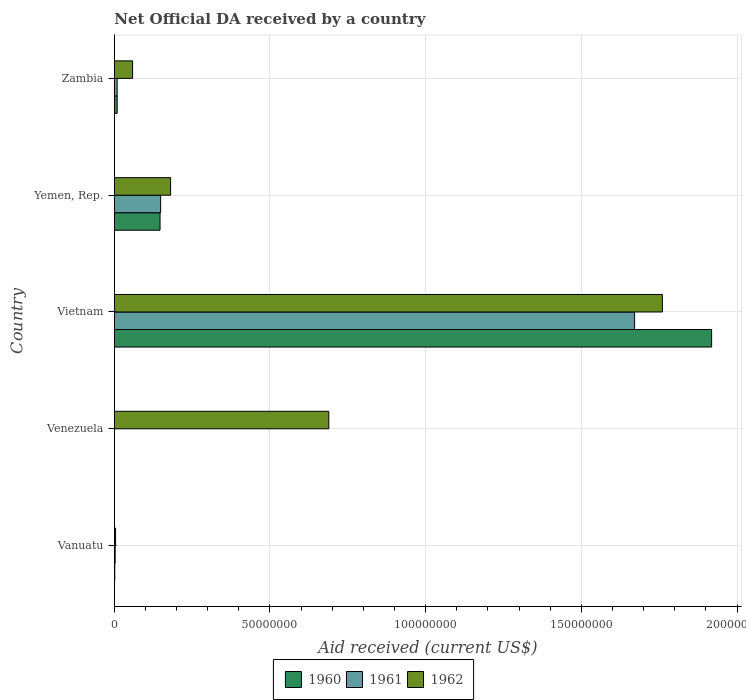Are the number of bars per tick equal to the number of legend labels?
Give a very brief answer. No. How many bars are there on the 4th tick from the top?
Ensure brevity in your answer.  1. What is the label of the 5th group of bars from the top?
Keep it short and to the point. Vanuatu. In how many cases, is the number of bars for a given country not equal to the number of legend labels?
Ensure brevity in your answer.  1. What is the net official development assistance aid received in 1961 in Vietnam?
Offer a terse response. 1.67e+08. Across all countries, what is the maximum net official development assistance aid received in 1960?
Give a very brief answer. 1.92e+08. In which country was the net official development assistance aid received in 1961 maximum?
Offer a very short reply. Vietnam. What is the total net official development assistance aid received in 1962 in the graph?
Offer a very short reply. 2.69e+08. What is the difference between the net official development assistance aid received in 1961 in Vietnam and that in Yemen, Rep.?
Give a very brief answer. 1.52e+08. What is the difference between the net official development assistance aid received in 1961 in Vietnam and the net official development assistance aid received in 1962 in Zambia?
Offer a very short reply. 1.61e+08. What is the average net official development assistance aid received in 1962 per country?
Keep it short and to the point. 5.39e+07. What is the difference between the net official development assistance aid received in 1960 and net official development assistance aid received in 1962 in Yemen, Rep.?
Offer a terse response. -3.39e+06. What is the ratio of the net official development assistance aid received in 1962 in Vanuatu to that in Yemen, Rep.?
Keep it short and to the point. 0.02. Is the difference between the net official development assistance aid received in 1960 in Vanuatu and Zambia greater than the difference between the net official development assistance aid received in 1962 in Vanuatu and Zambia?
Provide a short and direct response. Yes. What is the difference between the highest and the second highest net official development assistance aid received in 1961?
Your answer should be compact. 1.52e+08. What is the difference between the highest and the lowest net official development assistance aid received in 1962?
Offer a very short reply. 1.76e+08. In how many countries, is the net official development assistance aid received in 1961 greater than the average net official development assistance aid received in 1961 taken over all countries?
Offer a very short reply. 1. How many bars are there?
Give a very brief answer. 13. Are all the bars in the graph horizontal?
Your response must be concise. Yes. What is the difference between two consecutive major ticks on the X-axis?
Keep it short and to the point. 5.00e+07. Does the graph contain any zero values?
Make the answer very short. Yes. How are the legend labels stacked?
Give a very brief answer. Horizontal. What is the title of the graph?
Keep it short and to the point. Net Official DA received by a country. What is the label or title of the X-axis?
Offer a terse response. Aid received (current US$). What is the Aid received (current US$) of 1960 in Vanuatu?
Make the answer very short. 1.50e+05. What is the Aid received (current US$) in 1961 in Vanuatu?
Your answer should be very brief. 2.80e+05. What is the Aid received (current US$) of 1962 in Vanuatu?
Keep it short and to the point. 4.10e+05. What is the Aid received (current US$) in 1961 in Venezuela?
Provide a succinct answer. 0. What is the Aid received (current US$) of 1962 in Venezuela?
Offer a very short reply. 6.89e+07. What is the Aid received (current US$) of 1960 in Vietnam?
Provide a short and direct response. 1.92e+08. What is the Aid received (current US$) of 1961 in Vietnam?
Your response must be concise. 1.67e+08. What is the Aid received (current US$) in 1962 in Vietnam?
Keep it short and to the point. 1.76e+08. What is the Aid received (current US$) in 1960 in Yemen, Rep.?
Provide a succinct answer. 1.47e+07. What is the Aid received (current US$) of 1961 in Yemen, Rep.?
Provide a short and direct response. 1.49e+07. What is the Aid received (current US$) of 1962 in Yemen, Rep.?
Offer a terse response. 1.81e+07. What is the Aid received (current US$) in 1960 in Zambia?
Keep it short and to the point. 9.20e+05. What is the Aid received (current US$) in 1961 in Zambia?
Offer a terse response. 9.10e+05. What is the Aid received (current US$) in 1962 in Zambia?
Ensure brevity in your answer.  5.88e+06. Across all countries, what is the maximum Aid received (current US$) of 1960?
Offer a very short reply. 1.92e+08. Across all countries, what is the maximum Aid received (current US$) in 1961?
Provide a short and direct response. 1.67e+08. Across all countries, what is the maximum Aid received (current US$) of 1962?
Ensure brevity in your answer.  1.76e+08. Across all countries, what is the minimum Aid received (current US$) in 1960?
Keep it short and to the point. 0. Across all countries, what is the minimum Aid received (current US$) of 1961?
Ensure brevity in your answer.  0. Across all countries, what is the minimum Aid received (current US$) of 1962?
Keep it short and to the point. 4.10e+05. What is the total Aid received (current US$) in 1960 in the graph?
Offer a very short reply. 2.08e+08. What is the total Aid received (current US$) in 1961 in the graph?
Offer a very short reply. 1.83e+08. What is the total Aid received (current US$) of 1962 in the graph?
Your answer should be compact. 2.69e+08. What is the difference between the Aid received (current US$) of 1962 in Vanuatu and that in Venezuela?
Your answer should be compact. -6.85e+07. What is the difference between the Aid received (current US$) of 1960 in Vanuatu and that in Vietnam?
Provide a succinct answer. -1.92e+08. What is the difference between the Aid received (current US$) of 1961 in Vanuatu and that in Vietnam?
Offer a very short reply. -1.67e+08. What is the difference between the Aid received (current US$) in 1962 in Vanuatu and that in Vietnam?
Give a very brief answer. -1.76e+08. What is the difference between the Aid received (current US$) of 1960 in Vanuatu and that in Yemen, Rep.?
Your response must be concise. -1.45e+07. What is the difference between the Aid received (current US$) in 1961 in Vanuatu and that in Yemen, Rep.?
Your answer should be compact. -1.46e+07. What is the difference between the Aid received (current US$) in 1962 in Vanuatu and that in Yemen, Rep.?
Your response must be concise. -1.77e+07. What is the difference between the Aid received (current US$) in 1960 in Vanuatu and that in Zambia?
Keep it short and to the point. -7.70e+05. What is the difference between the Aid received (current US$) of 1961 in Vanuatu and that in Zambia?
Give a very brief answer. -6.30e+05. What is the difference between the Aid received (current US$) in 1962 in Vanuatu and that in Zambia?
Provide a succinct answer. -5.47e+06. What is the difference between the Aid received (current US$) in 1962 in Venezuela and that in Vietnam?
Keep it short and to the point. -1.07e+08. What is the difference between the Aid received (current US$) in 1962 in Venezuela and that in Yemen, Rep.?
Give a very brief answer. 5.08e+07. What is the difference between the Aid received (current US$) in 1962 in Venezuela and that in Zambia?
Provide a short and direct response. 6.30e+07. What is the difference between the Aid received (current US$) in 1960 in Vietnam and that in Yemen, Rep.?
Offer a very short reply. 1.77e+08. What is the difference between the Aid received (current US$) of 1961 in Vietnam and that in Yemen, Rep.?
Offer a terse response. 1.52e+08. What is the difference between the Aid received (current US$) in 1962 in Vietnam and that in Yemen, Rep.?
Provide a short and direct response. 1.58e+08. What is the difference between the Aid received (current US$) of 1960 in Vietnam and that in Zambia?
Ensure brevity in your answer.  1.91e+08. What is the difference between the Aid received (current US$) of 1961 in Vietnam and that in Zambia?
Provide a succinct answer. 1.66e+08. What is the difference between the Aid received (current US$) in 1962 in Vietnam and that in Zambia?
Keep it short and to the point. 1.70e+08. What is the difference between the Aid received (current US$) in 1960 in Yemen, Rep. and that in Zambia?
Provide a succinct answer. 1.38e+07. What is the difference between the Aid received (current US$) of 1961 in Yemen, Rep. and that in Zambia?
Offer a very short reply. 1.40e+07. What is the difference between the Aid received (current US$) of 1962 in Yemen, Rep. and that in Zambia?
Offer a very short reply. 1.22e+07. What is the difference between the Aid received (current US$) of 1960 in Vanuatu and the Aid received (current US$) of 1962 in Venezuela?
Ensure brevity in your answer.  -6.87e+07. What is the difference between the Aid received (current US$) in 1961 in Vanuatu and the Aid received (current US$) in 1962 in Venezuela?
Offer a terse response. -6.86e+07. What is the difference between the Aid received (current US$) in 1960 in Vanuatu and the Aid received (current US$) in 1961 in Vietnam?
Provide a short and direct response. -1.67e+08. What is the difference between the Aid received (current US$) in 1960 in Vanuatu and the Aid received (current US$) in 1962 in Vietnam?
Offer a terse response. -1.76e+08. What is the difference between the Aid received (current US$) in 1961 in Vanuatu and the Aid received (current US$) in 1962 in Vietnam?
Offer a terse response. -1.76e+08. What is the difference between the Aid received (current US$) in 1960 in Vanuatu and the Aid received (current US$) in 1961 in Yemen, Rep.?
Provide a short and direct response. -1.47e+07. What is the difference between the Aid received (current US$) of 1960 in Vanuatu and the Aid received (current US$) of 1962 in Yemen, Rep.?
Make the answer very short. -1.79e+07. What is the difference between the Aid received (current US$) in 1961 in Vanuatu and the Aid received (current US$) in 1962 in Yemen, Rep.?
Keep it short and to the point. -1.78e+07. What is the difference between the Aid received (current US$) of 1960 in Vanuatu and the Aid received (current US$) of 1961 in Zambia?
Offer a very short reply. -7.60e+05. What is the difference between the Aid received (current US$) in 1960 in Vanuatu and the Aid received (current US$) in 1962 in Zambia?
Your answer should be compact. -5.73e+06. What is the difference between the Aid received (current US$) in 1961 in Vanuatu and the Aid received (current US$) in 1962 in Zambia?
Make the answer very short. -5.60e+06. What is the difference between the Aid received (current US$) of 1960 in Vietnam and the Aid received (current US$) of 1961 in Yemen, Rep.?
Provide a short and direct response. 1.77e+08. What is the difference between the Aid received (current US$) of 1960 in Vietnam and the Aid received (current US$) of 1962 in Yemen, Rep.?
Provide a short and direct response. 1.74e+08. What is the difference between the Aid received (current US$) of 1961 in Vietnam and the Aid received (current US$) of 1962 in Yemen, Rep.?
Offer a terse response. 1.49e+08. What is the difference between the Aid received (current US$) of 1960 in Vietnam and the Aid received (current US$) of 1961 in Zambia?
Provide a short and direct response. 1.91e+08. What is the difference between the Aid received (current US$) in 1960 in Vietnam and the Aid received (current US$) in 1962 in Zambia?
Offer a terse response. 1.86e+08. What is the difference between the Aid received (current US$) in 1961 in Vietnam and the Aid received (current US$) in 1962 in Zambia?
Offer a terse response. 1.61e+08. What is the difference between the Aid received (current US$) of 1960 in Yemen, Rep. and the Aid received (current US$) of 1961 in Zambia?
Give a very brief answer. 1.38e+07. What is the difference between the Aid received (current US$) in 1960 in Yemen, Rep. and the Aid received (current US$) in 1962 in Zambia?
Make the answer very short. 8.81e+06. What is the difference between the Aid received (current US$) of 1961 in Yemen, Rep. and the Aid received (current US$) of 1962 in Zambia?
Keep it short and to the point. 9.00e+06. What is the average Aid received (current US$) in 1960 per country?
Your answer should be compact. 4.15e+07. What is the average Aid received (current US$) in 1961 per country?
Offer a terse response. 3.66e+07. What is the average Aid received (current US$) in 1962 per country?
Make the answer very short. 5.39e+07. What is the difference between the Aid received (current US$) of 1960 and Aid received (current US$) of 1961 in Vanuatu?
Ensure brevity in your answer.  -1.30e+05. What is the difference between the Aid received (current US$) of 1960 and Aid received (current US$) of 1962 in Vanuatu?
Offer a terse response. -2.60e+05. What is the difference between the Aid received (current US$) in 1960 and Aid received (current US$) in 1961 in Vietnam?
Give a very brief answer. 2.47e+07. What is the difference between the Aid received (current US$) of 1960 and Aid received (current US$) of 1962 in Vietnam?
Keep it short and to the point. 1.58e+07. What is the difference between the Aid received (current US$) in 1961 and Aid received (current US$) in 1962 in Vietnam?
Offer a very short reply. -8.92e+06. What is the difference between the Aid received (current US$) in 1960 and Aid received (current US$) in 1961 in Yemen, Rep.?
Keep it short and to the point. -1.90e+05. What is the difference between the Aid received (current US$) in 1960 and Aid received (current US$) in 1962 in Yemen, Rep.?
Provide a succinct answer. -3.39e+06. What is the difference between the Aid received (current US$) in 1961 and Aid received (current US$) in 1962 in Yemen, Rep.?
Provide a succinct answer. -3.20e+06. What is the difference between the Aid received (current US$) in 1960 and Aid received (current US$) in 1962 in Zambia?
Your answer should be very brief. -4.96e+06. What is the difference between the Aid received (current US$) of 1961 and Aid received (current US$) of 1962 in Zambia?
Provide a succinct answer. -4.97e+06. What is the ratio of the Aid received (current US$) in 1962 in Vanuatu to that in Venezuela?
Keep it short and to the point. 0.01. What is the ratio of the Aid received (current US$) of 1960 in Vanuatu to that in Vietnam?
Ensure brevity in your answer.  0. What is the ratio of the Aid received (current US$) in 1961 in Vanuatu to that in Vietnam?
Keep it short and to the point. 0. What is the ratio of the Aid received (current US$) of 1962 in Vanuatu to that in Vietnam?
Give a very brief answer. 0. What is the ratio of the Aid received (current US$) in 1960 in Vanuatu to that in Yemen, Rep.?
Make the answer very short. 0.01. What is the ratio of the Aid received (current US$) of 1961 in Vanuatu to that in Yemen, Rep.?
Provide a short and direct response. 0.02. What is the ratio of the Aid received (current US$) in 1962 in Vanuatu to that in Yemen, Rep.?
Your response must be concise. 0.02. What is the ratio of the Aid received (current US$) of 1960 in Vanuatu to that in Zambia?
Provide a short and direct response. 0.16. What is the ratio of the Aid received (current US$) of 1961 in Vanuatu to that in Zambia?
Keep it short and to the point. 0.31. What is the ratio of the Aid received (current US$) of 1962 in Vanuatu to that in Zambia?
Offer a very short reply. 0.07. What is the ratio of the Aid received (current US$) of 1962 in Venezuela to that in Vietnam?
Offer a very short reply. 0.39. What is the ratio of the Aid received (current US$) of 1962 in Venezuela to that in Yemen, Rep.?
Your answer should be very brief. 3.81. What is the ratio of the Aid received (current US$) in 1962 in Venezuela to that in Zambia?
Your answer should be compact. 11.72. What is the ratio of the Aid received (current US$) of 1960 in Vietnam to that in Yemen, Rep.?
Make the answer very short. 13.06. What is the ratio of the Aid received (current US$) of 1961 in Vietnam to that in Yemen, Rep.?
Keep it short and to the point. 11.23. What is the ratio of the Aid received (current US$) in 1962 in Vietnam to that in Yemen, Rep.?
Provide a succinct answer. 9.74. What is the ratio of the Aid received (current US$) of 1960 in Vietnam to that in Zambia?
Give a very brief answer. 208.53. What is the ratio of the Aid received (current US$) of 1961 in Vietnam to that in Zambia?
Make the answer very short. 183.64. What is the ratio of the Aid received (current US$) of 1962 in Vietnam to that in Zambia?
Your response must be concise. 29.94. What is the ratio of the Aid received (current US$) in 1960 in Yemen, Rep. to that in Zambia?
Offer a terse response. 15.97. What is the ratio of the Aid received (current US$) of 1961 in Yemen, Rep. to that in Zambia?
Give a very brief answer. 16.35. What is the ratio of the Aid received (current US$) of 1962 in Yemen, Rep. to that in Zambia?
Give a very brief answer. 3.07. What is the difference between the highest and the second highest Aid received (current US$) of 1960?
Provide a succinct answer. 1.77e+08. What is the difference between the highest and the second highest Aid received (current US$) in 1961?
Ensure brevity in your answer.  1.52e+08. What is the difference between the highest and the second highest Aid received (current US$) in 1962?
Ensure brevity in your answer.  1.07e+08. What is the difference between the highest and the lowest Aid received (current US$) in 1960?
Your response must be concise. 1.92e+08. What is the difference between the highest and the lowest Aid received (current US$) of 1961?
Your answer should be very brief. 1.67e+08. What is the difference between the highest and the lowest Aid received (current US$) in 1962?
Ensure brevity in your answer.  1.76e+08. 